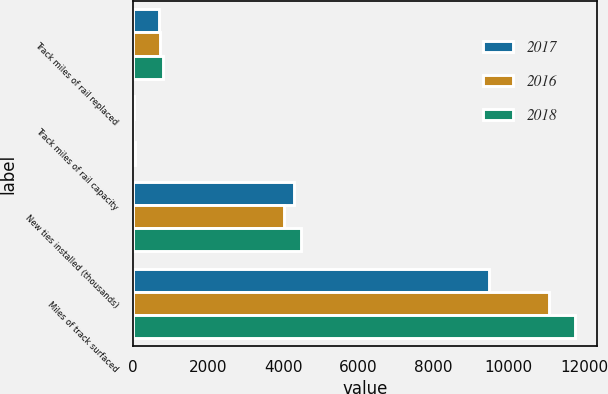<chart> <loc_0><loc_0><loc_500><loc_500><stacked_bar_chart><ecel><fcel>Track miles of rail replaced<fcel>Track miles of rail capacity<fcel>New ties installed (thousands)<fcel>Miles of track surfaced<nl><fcel>2017<fcel>700<fcel>39<fcel>4285<fcel>9466<nl><fcel>2016<fcel>731<fcel>11<fcel>4026<fcel>11071<nl><fcel>2018<fcel>791<fcel>52<fcel>4482<fcel>11764<nl></chart> 